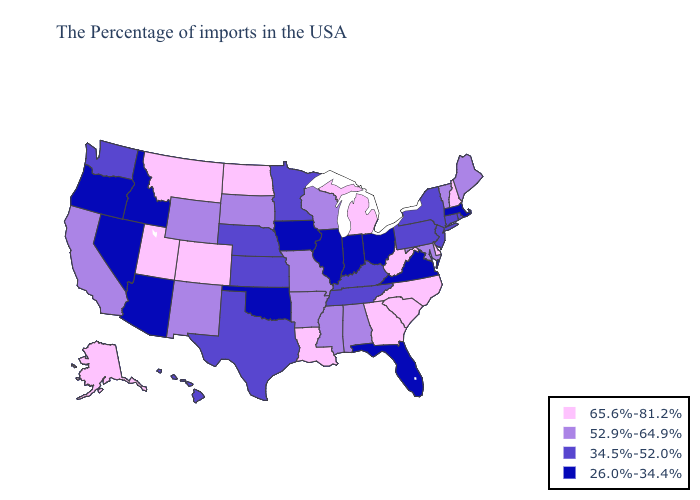What is the value of Alabama?
Short answer required. 52.9%-64.9%. Name the states that have a value in the range 65.6%-81.2%?
Write a very short answer. New Hampshire, Delaware, North Carolina, South Carolina, West Virginia, Georgia, Michigan, Louisiana, North Dakota, Colorado, Utah, Montana, Alaska. Name the states that have a value in the range 52.9%-64.9%?
Concise answer only. Maine, Vermont, Maryland, Alabama, Wisconsin, Mississippi, Missouri, Arkansas, South Dakota, Wyoming, New Mexico, California. What is the highest value in the USA?
Answer briefly. 65.6%-81.2%. What is the lowest value in the USA?
Concise answer only. 26.0%-34.4%. Is the legend a continuous bar?
Write a very short answer. No. What is the value of Oregon?
Answer briefly. 26.0%-34.4%. Among the states that border Alabama , does Georgia have the lowest value?
Quick response, please. No. What is the lowest value in the Northeast?
Be succinct. 26.0%-34.4%. Does California have the highest value in the USA?
Write a very short answer. No. What is the value of Connecticut?
Quick response, please. 34.5%-52.0%. Which states have the highest value in the USA?
Write a very short answer. New Hampshire, Delaware, North Carolina, South Carolina, West Virginia, Georgia, Michigan, Louisiana, North Dakota, Colorado, Utah, Montana, Alaska. What is the highest value in the USA?
Be succinct. 65.6%-81.2%. What is the value of Vermont?
Concise answer only. 52.9%-64.9%. What is the value of Georgia?
Give a very brief answer. 65.6%-81.2%. 